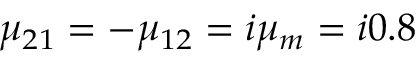<formula> <loc_0><loc_0><loc_500><loc_500>\mu _ { 2 1 } = - \mu _ { 1 2 } = i \mu _ { m } = i 0 . 8</formula> 